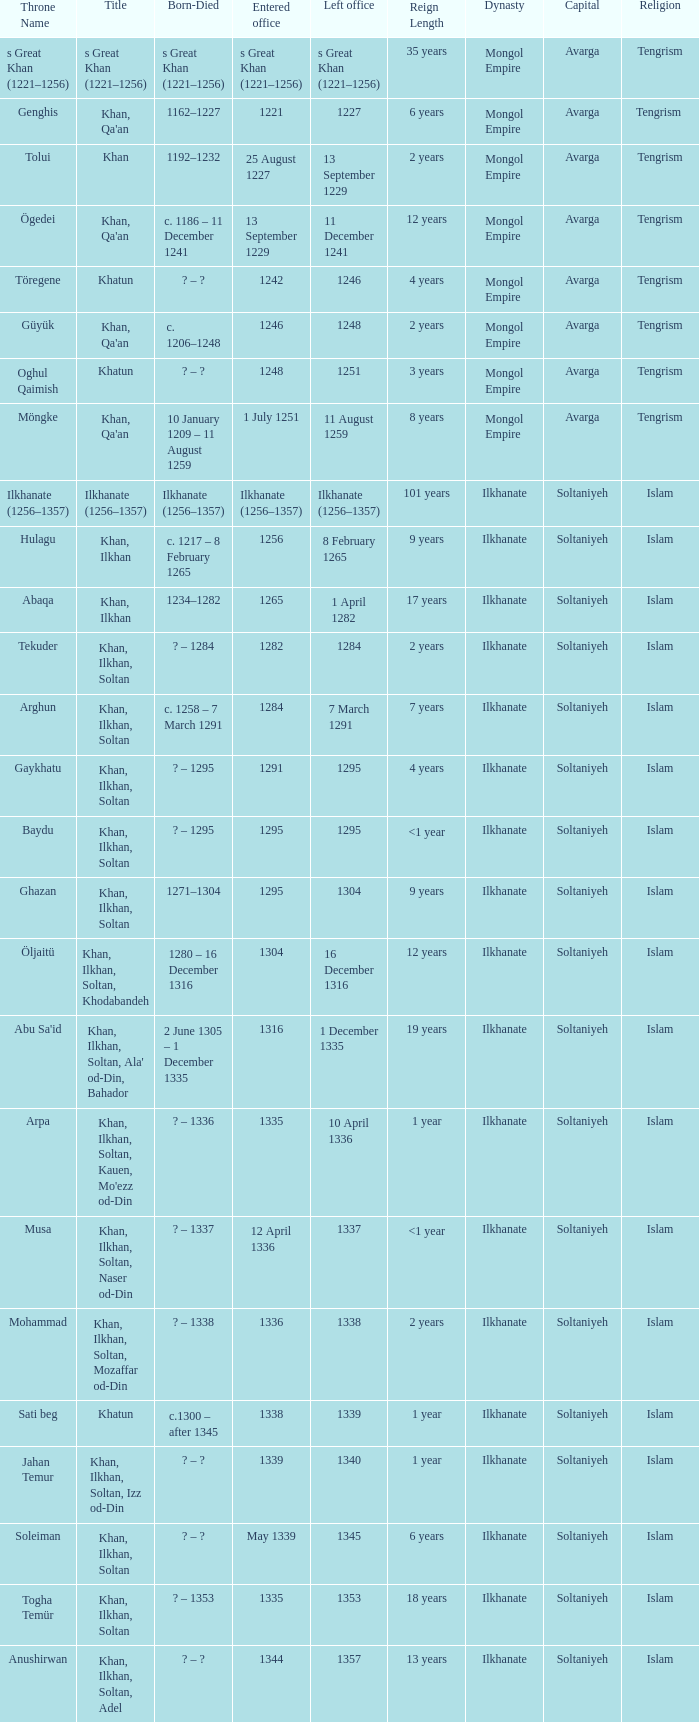What is the born-died that has office of 13 September 1229 as the entered? C. 1186 – 11 december 1241. 